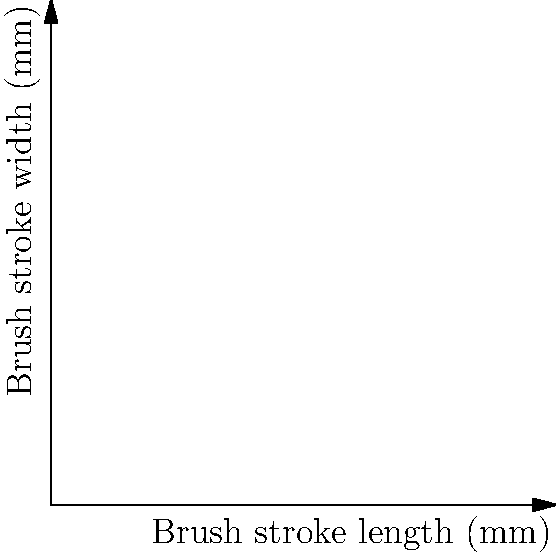As a museum curator analyzing potential art forgeries, you're presented with brush stroke data from a genuine painting and a suspected forgery. The graph shows the relationship between brush stroke length and width for both paintings. Based on the data, which machine learning technique would be most appropriate for identifying the forgery, and why? To answer this question, let's analyze the data and consider appropriate machine learning techniques:

1. Data representation: The graph shows two sets of data points, representing brush stroke measurements from a genuine painting (red) and a suspected forgery (blue).

2. Pattern observation: The two sets of points follow similar trends but have slight differences in their exact positions.

3. Problem type: This is a classification problem, where we need to distinguish between genuine and forged paintings based on brush stroke patterns.

4. Data characteristics:
   a. Low-dimensional: We have only two features (length and width).
   b. Small dataset: There are only a few data points for each class.
   c. Slight differences: The patterns are similar but not identical.

5. Suitable machine learning techniques:
   a. Support Vector Machines (SVM): Effective for low-dimensional data and can find subtle differences between classes.
   b. k-Nearest Neighbors (k-NN): Works well with small datasets and can capture local patterns.
   c. Decision Trees: Can handle non-linear relationships but may overfit with small datasets.

6. Best choice: Support Vector Machines (SVM)
   Reasons:
   - Can find an optimal hyperplane to separate the two classes, even with subtle differences.
   - Works well with low-dimensional data.
   - Less prone to overfitting compared to other methods when dealing with small datasets.
   - Can use kernel tricks to capture non-linear relationships if necessary.

7. Implementation:
   - Use the brush stroke length and width as features.
   - Train the SVM on a dataset of known genuine and forged paintings.
   - Apply the trained model to classify new, unknown paintings.
Answer: Support Vector Machines (SVM) 